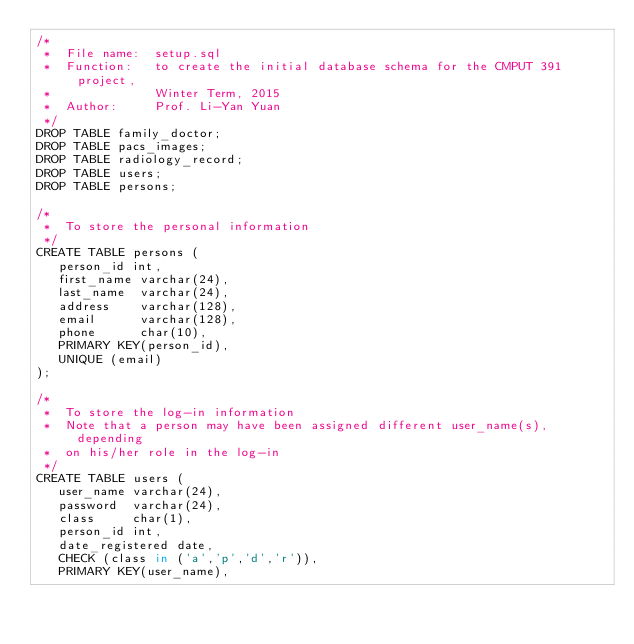Convert code to text. <code><loc_0><loc_0><loc_500><loc_500><_SQL_>/*
 *  File name:  setup.sql
 *  Function:   to create the initial database schema for the CMPUT 391 project,
 *              Winter Term, 2015
 *  Author:     Prof. Li-Yan Yuan
 */
DROP TABLE family_doctor;
DROP TABLE pacs_images;
DROP TABLE radiology_record;
DROP TABLE users;
DROP TABLE persons;

/*
 *  To store the personal information
 */
CREATE TABLE persons (
   person_id int,
   first_name varchar(24),
   last_name  varchar(24),
   address    varchar(128),
   email      varchar(128),
   phone      char(10),
   PRIMARY KEY(person_id),
   UNIQUE (email)
);

/*
 *  To store the log-in information
 *  Note that a person may have been assigned different user_name(s), depending
 *  on his/her role in the log-in  
 */
CREATE TABLE users (
   user_name varchar(24),
   password  varchar(24),
   class     char(1),
   person_id int,
   date_registered date,
   CHECK (class in ('a','p','d','r')),
   PRIMARY KEY(user_name),</code> 